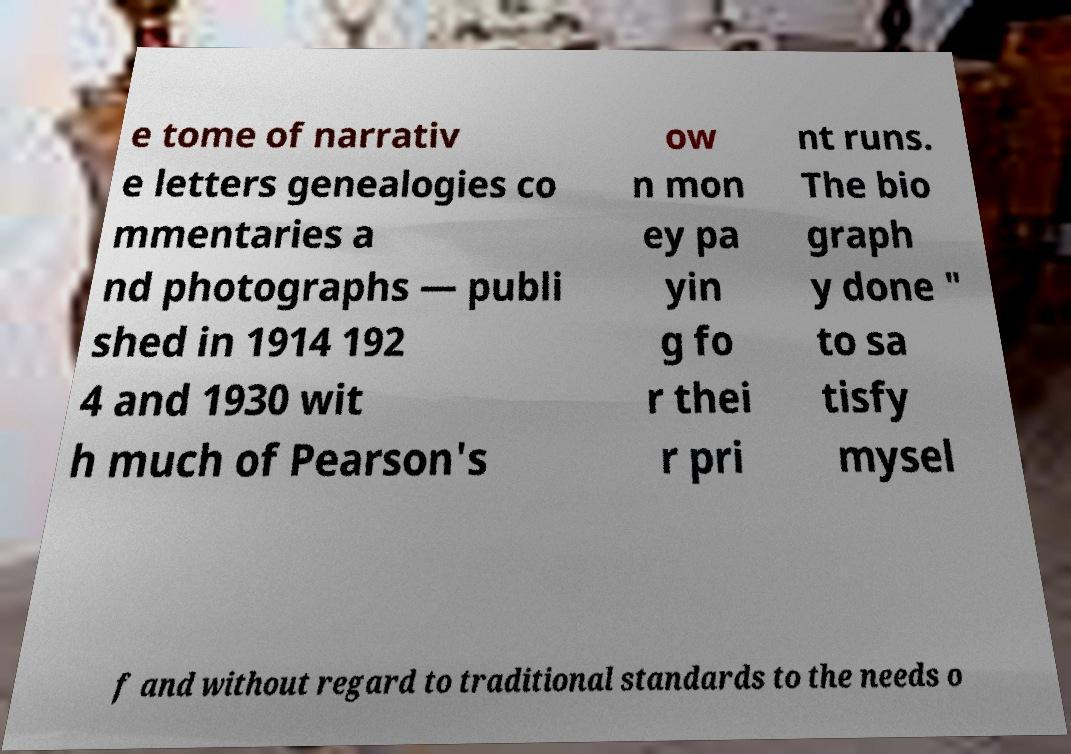There's text embedded in this image that I need extracted. Can you transcribe it verbatim? e tome of narrativ e letters genealogies co mmentaries a nd photographs — publi shed in 1914 192 4 and 1930 wit h much of Pearson's ow n mon ey pa yin g fo r thei r pri nt runs. The bio graph y done " to sa tisfy mysel f and without regard to traditional standards to the needs o 